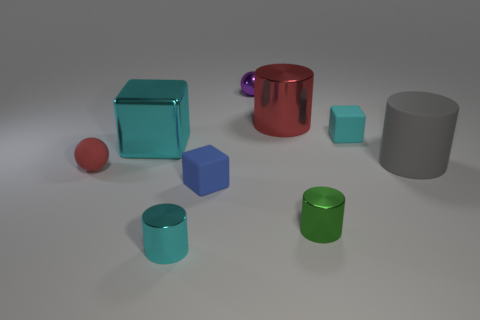What is the size of the cyan block that is made of the same material as the cyan cylinder?
Ensure brevity in your answer.  Large. Do the small purple metallic thing and the large thing to the right of the cyan rubber block have the same shape?
Give a very brief answer. No. The gray rubber cylinder has what size?
Keep it short and to the point. Large. Are there fewer red matte spheres to the right of the purple metallic thing than large brown shiny cubes?
Ensure brevity in your answer.  No. What number of red matte spheres have the same size as the cyan shiny cylinder?
Your response must be concise. 1. There is a big metallic object that is the same color as the matte ball; what shape is it?
Ensure brevity in your answer.  Cylinder. There is a rubber cube that is to the left of the cyan rubber cube; does it have the same color as the tiny ball on the left side of the blue rubber cube?
Ensure brevity in your answer.  No. What number of matte things are right of the red matte ball?
Offer a very short reply. 3. The shiny cylinder that is the same color as the matte ball is what size?
Give a very brief answer. Large. Are there any tiny green metal objects of the same shape as the large gray object?
Keep it short and to the point. Yes. 